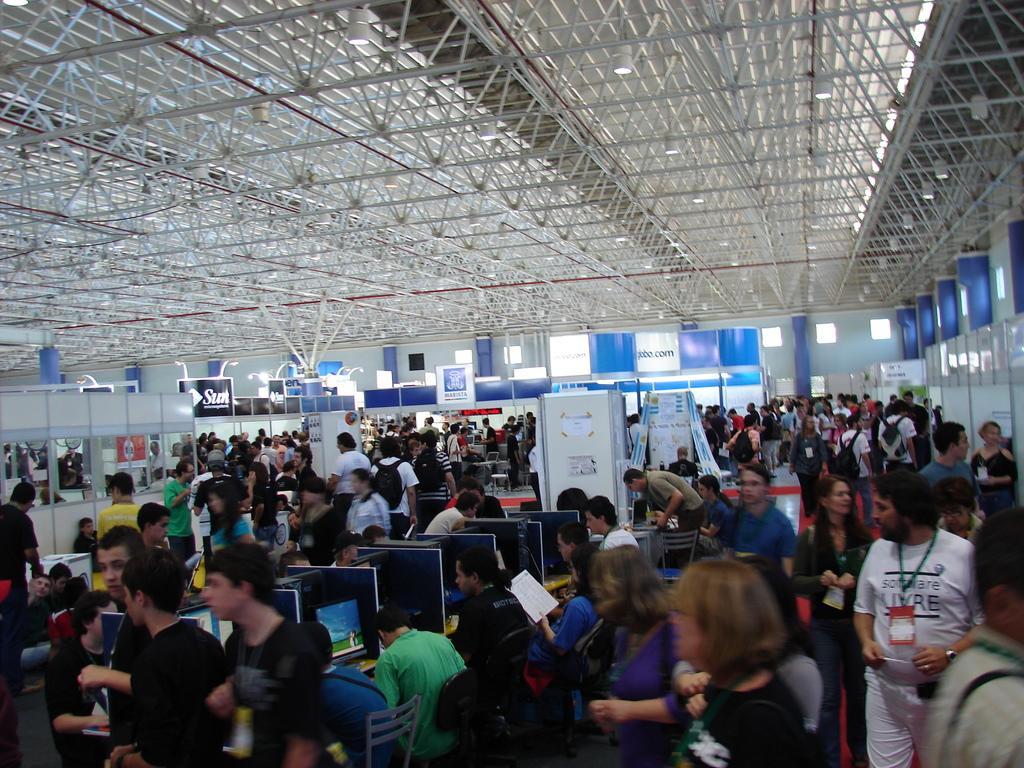Describe this image in one or two sentences. At the bottom of the image we can see many people standing and some of them are sitting. There are computers placed on the tables. We can see boards. In the background there is a door. At the top we can see lights. 